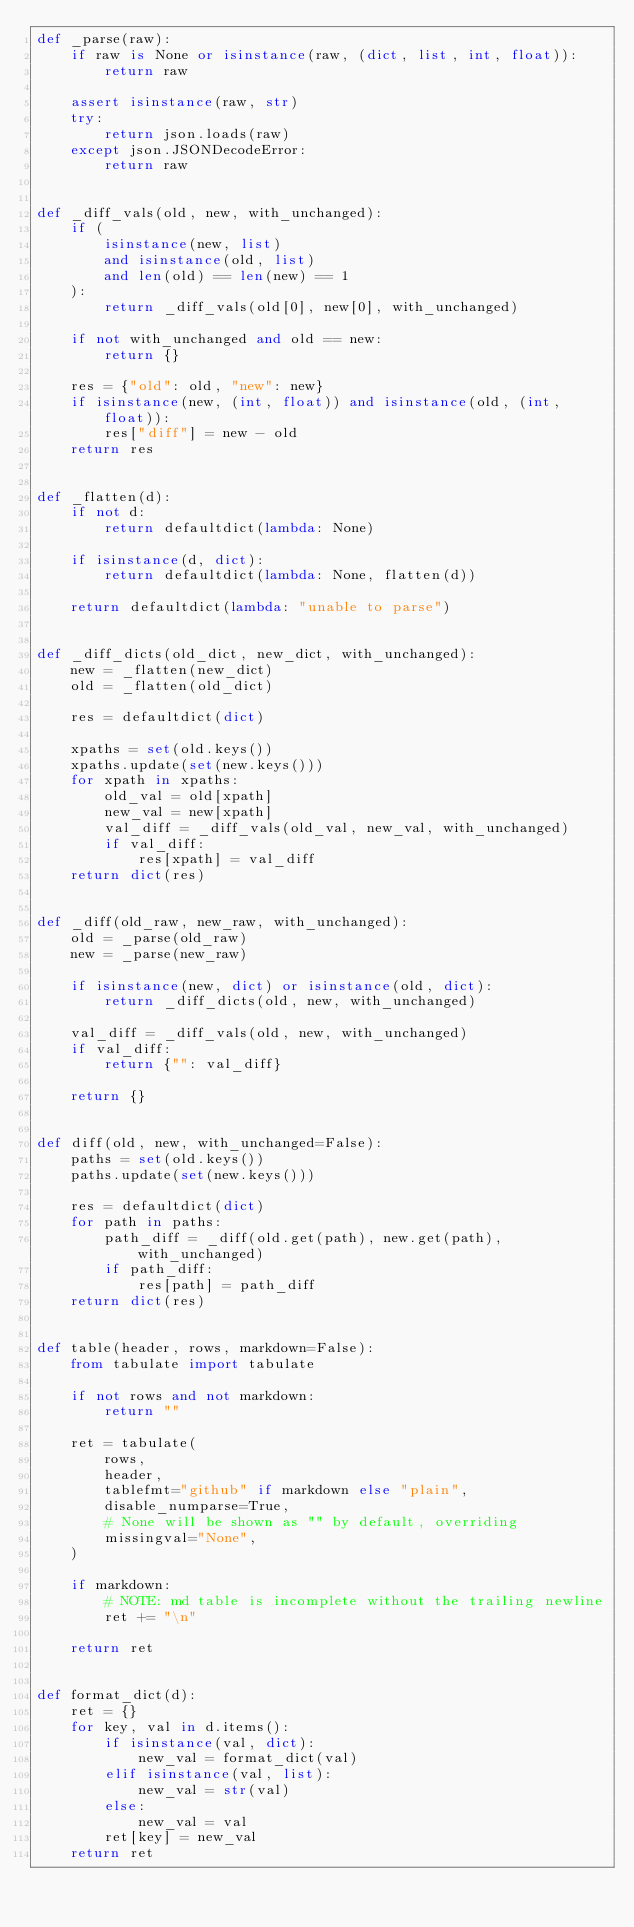<code> <loc_0><loc_0><loc_500><loc_500><_Python_>def _parse(raw):
    if raw is None or isinstance(raw, (dict, list, int, float)):
        return raw

    assert isinstance(raw, str)
    try:
        return json.loads(raw)
    except json.JSONDecodeError:
        return raw


def _diff_vals(old, new, with_unchanged):
    if (
        isinstance(new, list)
        and isinstance(old, list)
        and len(old) == len(new) == 1
    ):
        return _diff_vals(old[0], new[0], with_unchanged)

    if not with_unchanged and old == new:
        return {}

    res = {"old": old, "new": new}
    if isinstance(new, (int, float)) and isinstance(old, (int, float)):
        res["diff"] = new - old
    return res


def _flatten(d):
    if not d:
        return defaultdict(lambda: None)

    if isinstance(d, dict):
        return defaultdict(lambda: None, flatten(d))

    return defaultdict(lambda: "unable to parse")


def _diff_dicts(old_dict, new_dict, with_unchanged):
    new = _flatten(new_dict)
    old = _flatten(old_dict)

    res = defaultdict(dict)

    xpaths = set(old.keys())
    xpaths.update(set(new.keys()))
    for xpath in xpaths:
        old_val = old[xpath]
        new_val = new[xpath]
        val_diff = _diff_vals(old_val, new_val, with_unchanged)
        if val_diff:
            res[xpath] = val_diff
    return dict(res)


def _diff(old_raw, new_raw, with_unchanged):
    old = _parse(old_raw)
    new = _parse(new_raw)

    if isinstance(new, dict) or isinstance(old, dict):
        return _diff_dicts(old, new, with_unchanged)

    val_diff = _diff_vals(old, new, with_unchanged)
    if val_diff:
        return {"": val_diff}

    return {}


def diff(old, new, with_unchanged=False):
    paths = set(old.keys())
    paths.update(set(new.keys()))

    res = defaultdict(dict)
    for path in paths:
        path_diff = _diff(old.get(path), new.get(path), with_unchanged)
        if path_diff:
            res[path] = path_diff
    return dict(res)


def table(header, rows, markdown=False):
    from tabulate import tabulate

    if not rows and not markdown:
        return ""

    ret = tabulate(
        rows,
        header,
        tablefmt="github" if markdown else "plain",
        disable_numparse=True,
        # None will be shown as "" by default, overriding
        missingval="None",
    )

    if markdown:
        # NOTE: md table is incomplete without the trailing newline
        ret += "\n"

    return ret


def format_dict(d):
    ret = {}
    for key, val in d.items():
        if isinstance(val, dict):
            new_val = format_dict(val)
        elif isinstance(val, list):
            new_val = str(val)
        else:
            new_val = val
        ret[key] = new_val
    return ret
</code> 